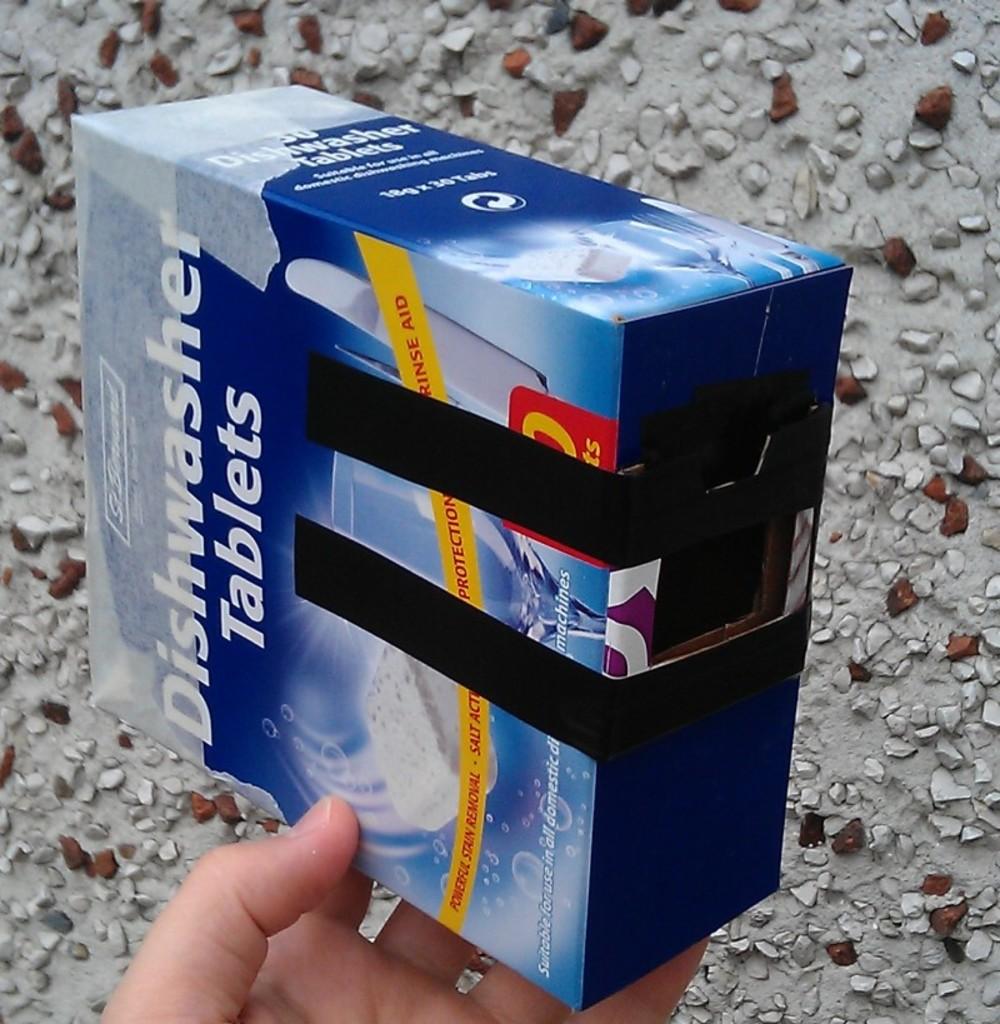What kinds of tablets are these?
Your response must be concise. Dishwasher. 